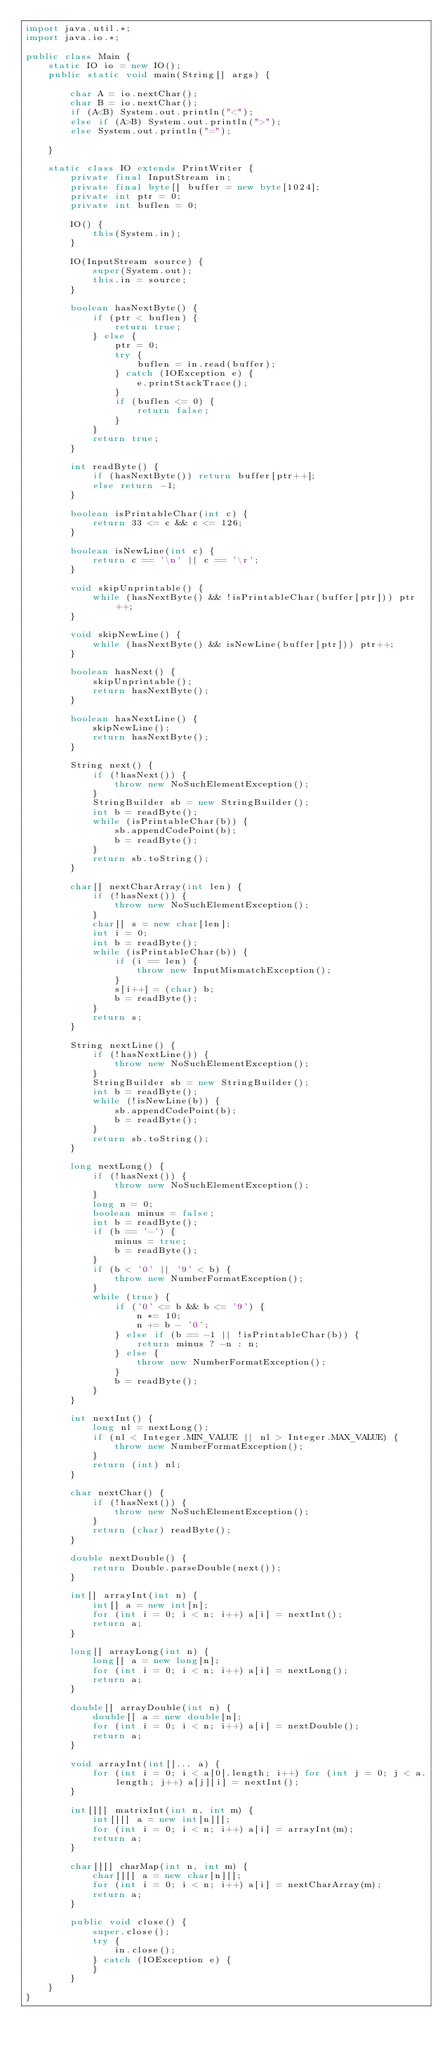Convert code to text. <code><loc_0><loc_0><loc_500><loc_500><_Java_>import java.util.*;
import java.io.*;

public class Main {
    static IO io = new IO();
    public static void main(String[] args) {

        char A = io.nextChar();
        char B = io.nextChar();
        if (A<B) System.out.println("<");
        else if (A>B) System.out.println(">");
        else System.out.println("=");

    }

    static class IO extends PrintWriter {
        private final InputStream in;
        private final byte[] buffer = new byte[1024];
        private int ptr = 0;
        private int buflen = 0;

        IO() {
            this(System.in);
        }

        IO(InputStream source) {
            super(System.out);
            this.in = source;
        }

        boolean hasNextByte() {
            if (ptr < buflen) {
                return true;
            } else {
                ptr = 0;
                try {
                    buflen = in.read(buffer);
                } catch (IOException e) {
                    e.printStackTrace();
                }
                if (buflen <= 0) {
                    return false;
                }
            }
            return true;
        }

        int readByte() {
            if (hasNextByte()) return buffer[ptr++];
            else return -1;
        }

        boolean isPrintableChar(int c) {
            return 33 <= c && c <= 126;
        }

        boolean isNewLine(int c) {
            return c == '\n' || c == '\r';
        }

        void skipUnprintable() {
            while (hasNextByte() && !isPrintableChar(buffer[ptr])) ptr++;
        }

        void skipNewLine() {
            while (hasNextByte() && isNewLine(buffer[ptr])) ptr++;
        }

        boolean hasNext() {
            skipUnprintable();
            return hasNextByte();
        }

        boolean hasNextLine() {
            skipNewLine();
            return hasNextByte();
        }

        String next() {
            if (!hasNext()) {
                throw new NoSuchElementException();
            }
            StringBuilder sb = new StringBuilder();
            int b = readByte();
            while (isPrintableChar(b)) {
                sb.appendCodePoint(b);
                b = readByte();
            }
            return sb.toString();
        }

        char[] nextCharArray(int len) {
            if (!hasNext()) {
                throw new NoSuchElementException();
            }
            char[] s = new char[len];
            int i = 0;
            int b = readByte();
            while (isPrintableChar(b)) {
                if (i == len) {
                    throw new InputMismatchException();
                }
                s[i++] = (char) b;
                b = readByte();
            }
            return s;
        }

        String nextLine() {
            if (!hasNextLine()) {
                throw new NoSuchElementException();
            }
            StringBuilder sb = new StringBuilder();
            int b = readByte();
            while (!isNewLine(b)) {
                sb.appendCodePoint(b);
                b = readByte();
            }
            return sb.toString();
        }

        long nextLong() {
            if (!hasNext()) {
                throw new NoSuchElementException();
            }
            long n = 0;
            boolean minus = false;
            int b = readByte();
            if (b == '-') {
                minus = true;
                b = readByte();
            }
            if (b < '0' || '9' < b) {
                throw new NumberFormatException();
            }
            while (true) {
                if ('0' <= b && b <= '9') {
                    n *= 10;
                    n += b - '0';
                } else if (b == -1 || !isPrintableChar(b)) {
                    return minus ? -n : n;
                } else {
                    throw new NumberFormatException();
                }
                b = readByte();
            }
        }

        int nextInt() {
            long nl = nextLong();
            if (nl < Integer.MIN_VALUE || nl > Integer.MAX_VALUE) {
                throw new NumberFormatException();
            }
            return (int) nl;
        }

        char nextChar() {
            if (!hasNext()) {
                throw new NoSuchElementException();
            }
            return (char) readByte();
        }

        double nextDouble() {
            return Double.parseDouble(next());
        }

        int[] arrayInt(int n) {
            int[] a = new int[n];
            for (int i = 0; i < n; i++) a[i] = nextInt();
            return a;
        }

        long[] arrayLong(int n) {
            long[] a = new long[n];
            for (int i = 0; i < n; i++) a[i] = nextLong();
            return a;
        }

        double[] arrayDouble(int n) {
            double[] a = new double[n];
            for (int i = 0; i < n; i++) a[i] = nextDouble();
            return a;
        }

        void arrayInt(int[]... a) {
            for (int i = 0; i < a[0].length; i++) for (int j = 0; j < a.length; j++) a[j][i] = nextInt();
        }

        int[][] matrixInt(int n, int m) {
            int[][] a = new int[n][];
            for (int i = 0; i < n; i++) a[i] = arrayInt(m);
            return a;
        }

        char[][] charMap(int n, int m) {
            char[][] a = new char[n][];
            for (int i = 0; i < n; i++) a[i] = nextCharArray(m);
            return a;
        }

        public void close() {
            super.close();
            try {
                in.close();
            } catch (IOException e) {
            }
        }
    }
}
</code> 